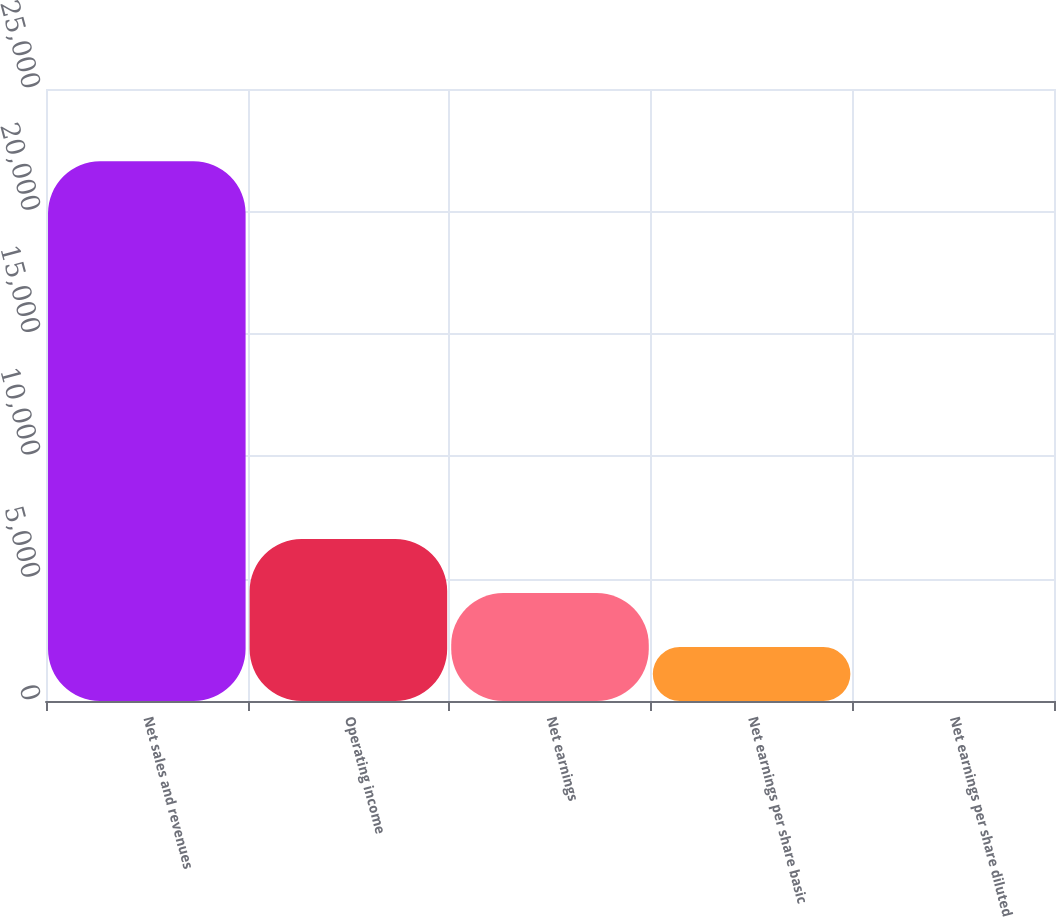<chart> <loc_0><loc_0><loc_500><loc_500><bar_chart><fcel>Net sales and revenues<fcel>Operating income<fcel>Net earnings<fcel>Net earnings per share basic<fcel>Net earnings per share diluted<nl><fcel>22046<fcel>6615.88<fcel>4411.58<fcel>2207.28<fcel>2.98<nl></chart> 